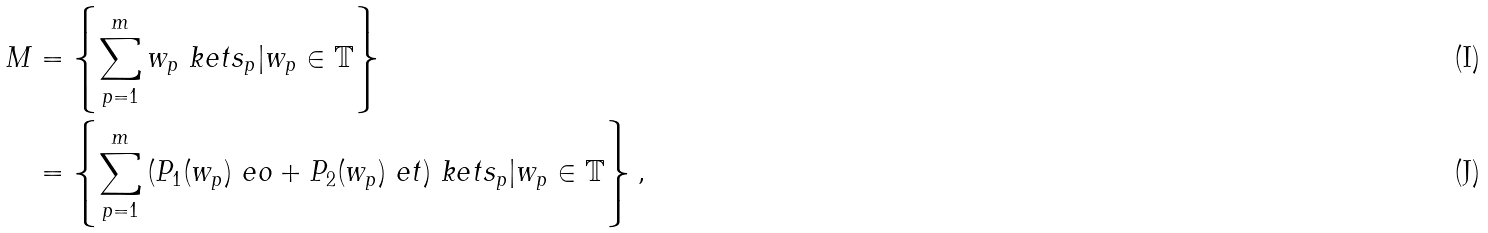<formula> <loc_0><loc_0><loc_500><loc_500>M & = \left \{ \sum _ { p = 1 } ^ { m } { w _ { p } \ k e t { s _ { p } } } | w _ { p } \in \mathbb { T } \right \} \\ & = \left \{ \sum _ { p = 1 } ^ { m } { ( P _ { 1 } ( w _ { p } ) \ e o + P _ { 2 } ( w _ { p } ) \ e t ) \ k e t { s _ { p } } } | w _ { p } \in \mathbb { T } \right \} ,</formula> 